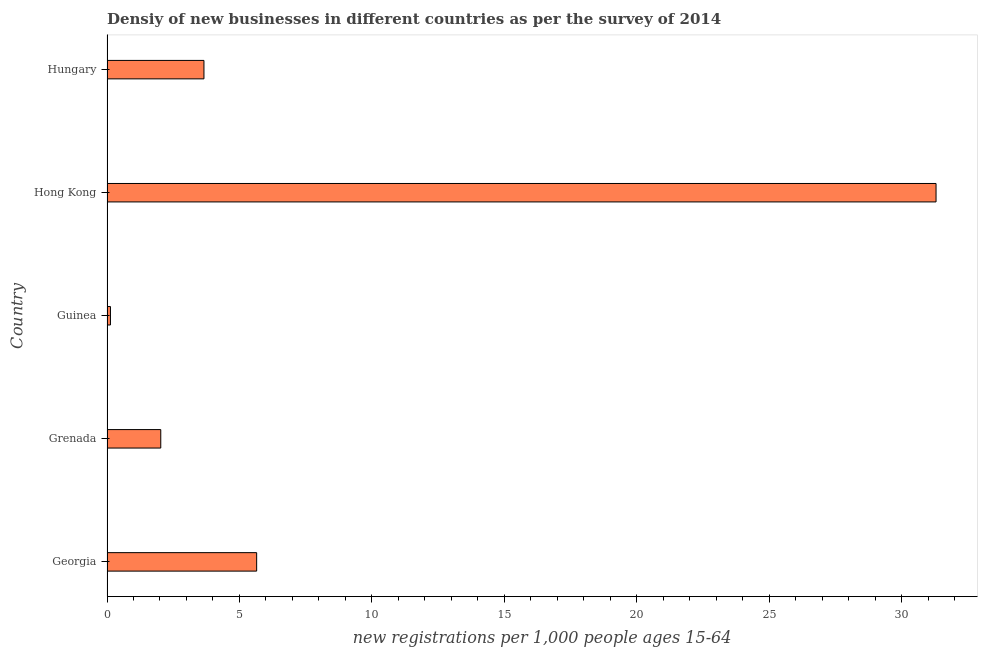Does the graph contain any zero values?
Give a very brief answer. No. What is the title of the graph?
Make the answer very short. Densiy of new businesses in different countries as per the survey of 2014. What is the label or title of the X-axis?
Provide a short and direct response. New registrations per 1,0 people ages 15-64. What is the label or title of the Y-axis?
Your answer should be very brief. Country. What is the density of new business in Grenada?
Provide a succinct answer. 2.03. Across all countries, what is the maximum density of new business?
Your answer should be compact. 31.3. Across all countries, what is the minimum density of new business?
Your answer should be very brief. 0.13. In which country was the density of new business maximum?
Your answer should be very brief. Hong Kong. In which country was the density of new business minimum?
Keep it short and to the point. Guinea. What is the sum of the density of new business?
Keep it short and to the point. 42.77. What is the difference between the density of new business in Georgia and Hungary?
Provide a short and direct response. 1.99. What is the average density of new business per country?
Make the answer very short. 8.55. What is the median density of new business?
Give a very brief answer. 3.66. In how many countries, is the density of new business greater than 6 ?
Offer a terse response. 1. What is the ratio of the density of new business in Georgia to that in Hungary?
Keep it short and to the point. 1.54. Is the density of new business in Georgia less than that in Guinea?
Your response must be concise. No. What is the difference between the highest and the second highest density of new business?
Keep it short and to the point. 25.65. What is the difference between the highest and the lowest density of new business?
Your answer should be compact. 31.17. Are all the bars in the graph horizontal?
Your response must be concise. Yes. What is the difference between two consecutive major ticks on the X-axis?
Give a very brief answer. 5. Are the values on the major ticks of X-axis written in scientific E-notation?
Provide a short and direct response. No. What is the new registrations per 1,000 people ages 15-64 in Georgia?
Provide a short and direct response. 5.65. What is the new registrations per 1,000 people ages 15-64 of Grenada?
Your response must be concise. 2.03. What is the new registrations per 1,000 people ages 15-64 in Guinea?
Offer a very short reply. 0.13. What is the new registrations per 1,000 people ages 15-64 in Hong Kong?
Keep it short and to the point. 31.3. What is the new registrations per 1,000 people ages 15-64 of Hungary?
Give a very brief answer. 3.66. What is the difference between the new registrations per 1,000 people ages 15-64 in Georgia and Grenada?
Make the answer very short. 3.62. What is the difference between the new registrations per 1,000 people ages 15-64 in Georgia and Guinea?
Offer a terse response. 5.52. What is the difference between the new registrations per 1,000 people ages 15-64 in Georgia and Hong Kong?
Ensure brevity in your answer.  -25.65. What is the difference between the new registrations per 1,000 people ages 15-64 in Georgia and Hungary?
Give a very brief answer. 1.99. What is the difference between the new registrations per 1,000 people ages 15-64 in Grenada and Guinea?
Provide a succinct answer. 1.9. What is the difference between the new registrations per 1,000 people ages 15-64 in Grenada and Hong Kong?
Provide a short and direct response. -29.27. What is the difference between the new registrations per 1,000 people ages 15-64 in Grenada and Hungary?
Give a very brief answer. -1.63. What is the difference between the new registrations per 1,000 people ages 15-64 in Guinea and Hong Kong?
Keep it short and to the point. -31.17. What is the difference between the new registrations per 1,000 people ages 15-64 in Guinea and Hungary?
Make the answer very short. -3.53. What is the difference between the new registrations per 1,000 people ages 15-64 in Hong Kong and Hungary?
Ensure brevity in your answer.  27.64. What is the ratio of the new registrations per 1,000 people ages 15-64 in Georgia to that in Grenada?
Provide a succinct answer. 2.78. What is the ratio of the new registrations per 1,000 people ages 15-64 in Georgia to that in Guinea?
Your answer should be compact. 43.46. What is the ratio of the new registrations per 1,000 people ages 15-64 in Georgia to that in Hong Kong?
Make the answer very short. 0.18. What is the ratio of the new registrations per 1,000 people ages 15-64 in Georgia to that in Hungary?
Ensure brevity in your answer.  1.54. What is the ratio of the new registrations per 1,000 people ages 15-64 in Grenada to that in Guinea?
Ensure brevity in your answer.  15.62. What is the ratio of the new registrations per 1,000 people ages 15-64 in Grenada to that in Hong Kong?
Keep it short and to the point. 0.07. What is the ratio of the new registrations per 1,000 people ages 15-64 in Grenada to that in Hungary?
Give a very brief answer. 0.56. What is the ratio of the new registrations per 1,000 people ages 15-64 in Guinea to that in Hong Kong?
Your answer should be compact. 0. What is the ratio of the new registrations per 1,000 people ages 15-64 in Guinea to that in Hungary?
Make the answer very short. 0.04. What is the ratio of the new registrations per 1,000 people ages 15-64 in Hong Kong to that in Hungary?
Your answer should be very brief. 8.55. 